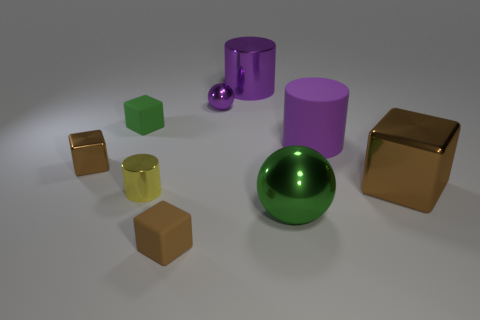Subtract all purple spheres. How many brown blocks are left? 3 Add 1 small purple metallic spheres. How many objects exist? 10 Subtract all cylinders. How many objects are left? 6 Add 3 tiny green matte cubes. How many tiny green matte cubes are left? 4 Add 8 yellow shiny objects. How many yellow shiny objects exist? 9 Subtract 0 green cylinders. How many objects are left? 9 Subtract all large yellow cylinders. Subtract all small brown things. How many objects are left? 7 